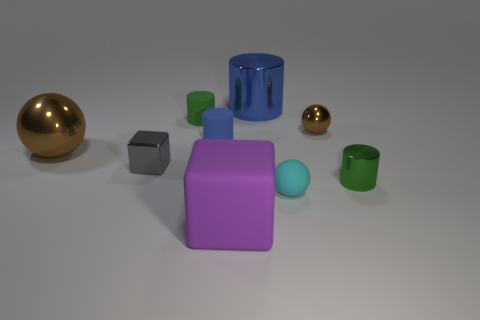What number of spheres are big brown shiny objects or cyan objects?
Your response must be concise. 2. There is a metallic cylinder behind the shiny thing that is left of the small gray thing; how many big blue cylinders are to the right of it?
Provide a short and direct response. 0. What material is the big object that is the same color as the tiny metallic ball?
Give a very brief answer. Metal. Is the number of big cyan cylinders greater than the number of tiny gray objects?
Keep it short and to the point. No. Is the gray thing the same size as the green shiny cylinder?
Offer a terse response. Yes. How many objects are either small gray objects or large rubber things?
Provide a short and direct response. 2. What is the shape of the brown shiny thing that is right of the green cylinder on the left side of the metal ball that is to the right of the small gray metallic cube?
Offer a very short reply. Sphere. Is the small cyan sphere in front of the large blue object made of the same material as the blue cylinder to the left of the purple matte object?
Make the answer very short. Yes. What is the material of the purple object that is the same shape as the small gray metal thing?
Your answer should be compact. Rubber. Is there anything else that is the same size as the purple thing?
Give a very brief answer. Yes. 